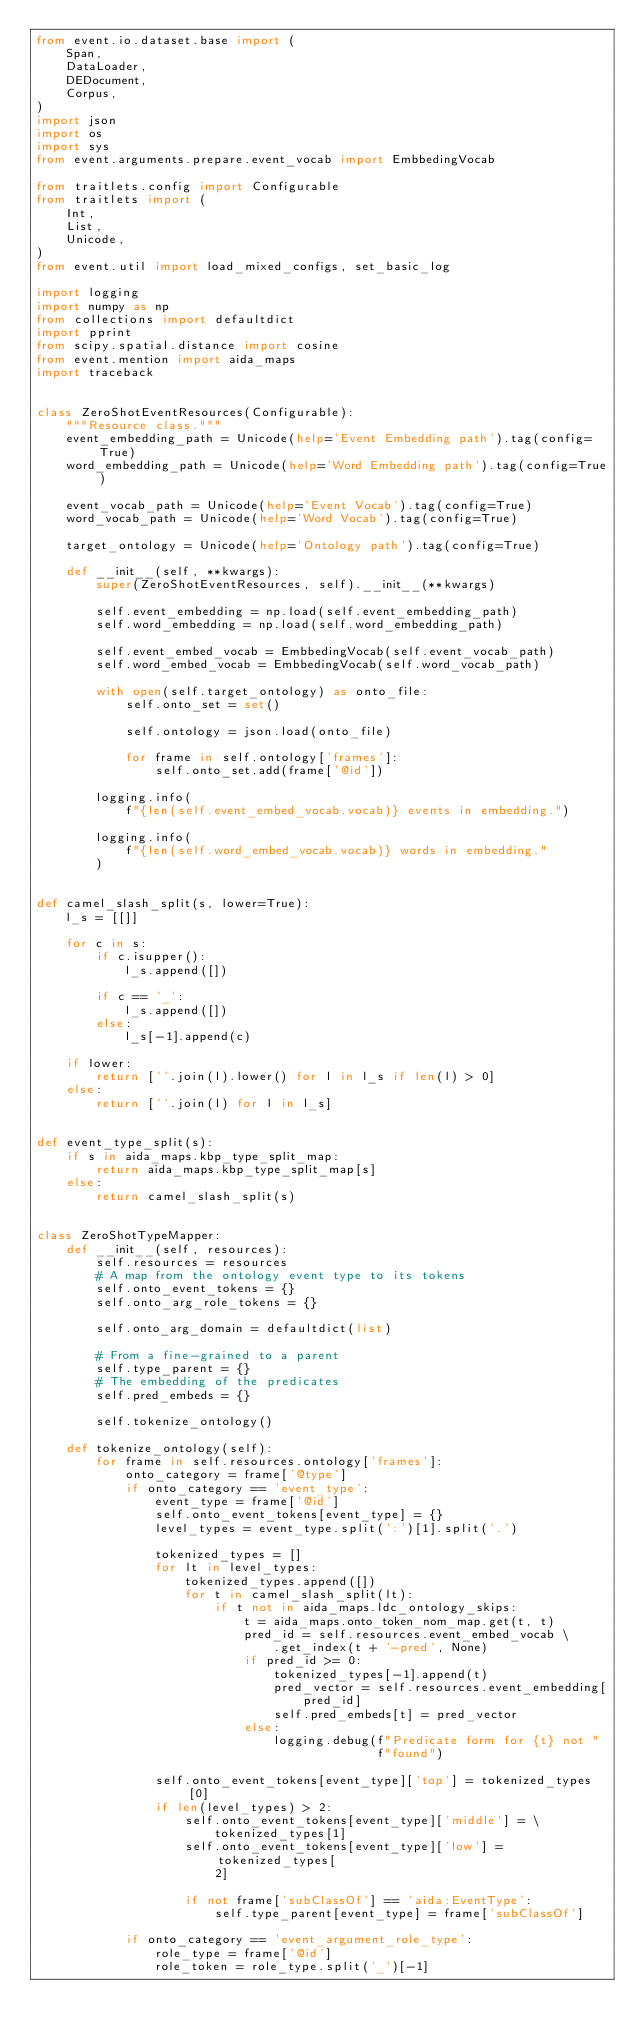<code> <loc_0><loc_0><loc_500><loc_500><_Python_>from event.io.dataset.base import (
    Span,
    DataLoader,
    DEDocument,
    Corpus,
)
import json
import os
import sys
from event.arguments.prepare.event_vocab import EmbbedingVocab

from traitlets.config import Configurable
from traitlets import (
    Int,
    List,
    Unicode,
)
from event.util import load_mixed_configs, set_basic_log

import logging
import numpy as np
from collections import defaultdict
import pprint
from scipy.spatial.distance import cosine
from event.mention import aida_maps
import traceback


class ZeroShotEventResources(Configurable):
    """Resource class."""
    event_embedding_path = Unicode(help='Event Embedding path').tag(config=True)
    word_embedding_path = Unicode(help='Word Embedding path').tag(config=True)

    event_vocab_path = Unicode(help='Event Vocab').tag(config=True)
    word_vocab_path = Unicode(help='Word Vocab').tag(config=True)

    target_ontology = Unicode(help='Ontology path').tag(config=True)

    def __init__(self, **kwargs):
        super(ZeroShotEventResources, self).__init__(**kwargs)

        self.event_embedding = np.load(self.event_embedding_path)
        self.word_embedding = np.load(self.word_embedding_path)

        self.event_embed_vocab = EmbbedingVocab(self.event_vocab_path)
        self.word_embed_vocab = EmbbedingVocab(self.word_vocab_path)

        with open(self.target_ontology) as onto_file:
            self.onto_set = set()

            self.ontology = json.load(onto_file)

            for frame in self.ontology['frames']:
                self.onto_set.add(frame['@id'])

        logging.info(
            f"{len(self.event_embed_vocab.vocab)} events in embedding.")

        logging.info(
            f"{len(self.word_embed_vocab.vocab)} words in embedding."
        )


def camel_slash_split(s, lower=True):
    l_s = [[]]

    for c in s:
        if c.isupper():
            l_s.append([])

        if c == '_':
            l_s.append([])
        else:
            l_s[-1].append(c)

    if lower:
        return [''.join(l).lower() for l in l_s if len(l) > 0]
    else:
        return [''.join(l) for l in l_s]


def event_type_split(s):
    if s in aida_maps.kbp_type_split_map:
        return aida_maps.kbp_type_split_map[s]
    else:
        return camel_slash_split(s)


class ZeroShotTypeMapper:
    def __init__(self, resources):
        self.resources = resources
        # A map from the ontology event type to its tokens
        self.onto_event_tokens = {}
        self.onto_arg_role_tokens = {}

        self.onto_arg_domain = defaultdict(list)

        # From a fine-grained to a parent
        self.type_parent = {}
        # The embedding of the predicates
        self.pred_embeds = {}

        self.tokenize_ontology()

    def tokenize_ontology(self):
        for frame in self.resources.ontology['frames']:
            onto_category = frame['@type']
            if onto_category == 'event_type':
                event_type = frame['@id']
                self.onto_event_tokens[event_type] = {}
                level_types = event_type.split(':')[1].split('.')

                tokenized_types = []
                for lt in level_types:
                    tokenized_types.append([])
                    for t in camel_slash_split(lt):
                        if t not in aida_maps.ldc_ontology_skips:
                            t = aida_maps.onto_token_nom_map.get(t, t)
                            pred_id = self.resources.event_embed_vocab \
                                .get_index(t + '-pred', None)
                            if pred_id >= 0:
                                tokenized_types[-1].append(t)
                                pred_vector = self.resources.event_embedding[
                                    pred_id]
                                self.pred_embeds[t] = pred_vector
                            else:
                                logging.debug(f"Predicate form for {t} not "
                                              f"found")

                self.onto_event_tokens[event_type]['top'] = tokenized_types[0]
                if len(level_types) > 2:
                    self.onto_event_tokens[event_type]['middle'] = \
                        tokenized_types[1]
                    self.onto_event_tokens[event_type]['low'] = tokenized_types[
                        2]

                    if not frame['subClassOf'] == 'aida:EventType':
                        self.type_parent[event_type] = frame['subClassOf']

            if onto_category == 'event_argument_role_type':
                role_type = frame['@id']
                role_token = role_type.split('_')[-1]</code> 